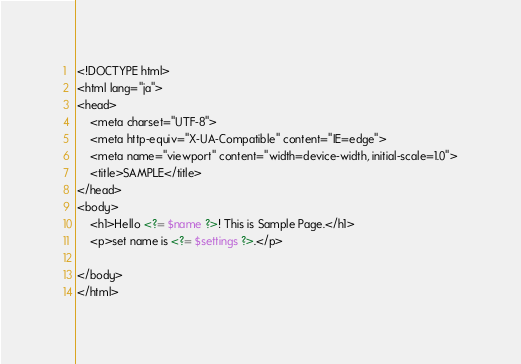<code> <loc_0><loc_0><loc_500><loc_500><_PHP_><!DOCTYPE html>
<html lang="ja">
<head>
    <meta charset="UTF-8">
    <meta http-equiv="X-UA-Compatible" content="IE=edge">
    <meta name="viewport" content="width=device-width, initial-scale=1.0">
    <title>SAMPLE</title>
</head>
<body>
    <h1>Hello <?= $name ?>! This is Sample Page.</h1>
    <p>set name is <?= $settings ?>.</p>

</body>
</html></code> 